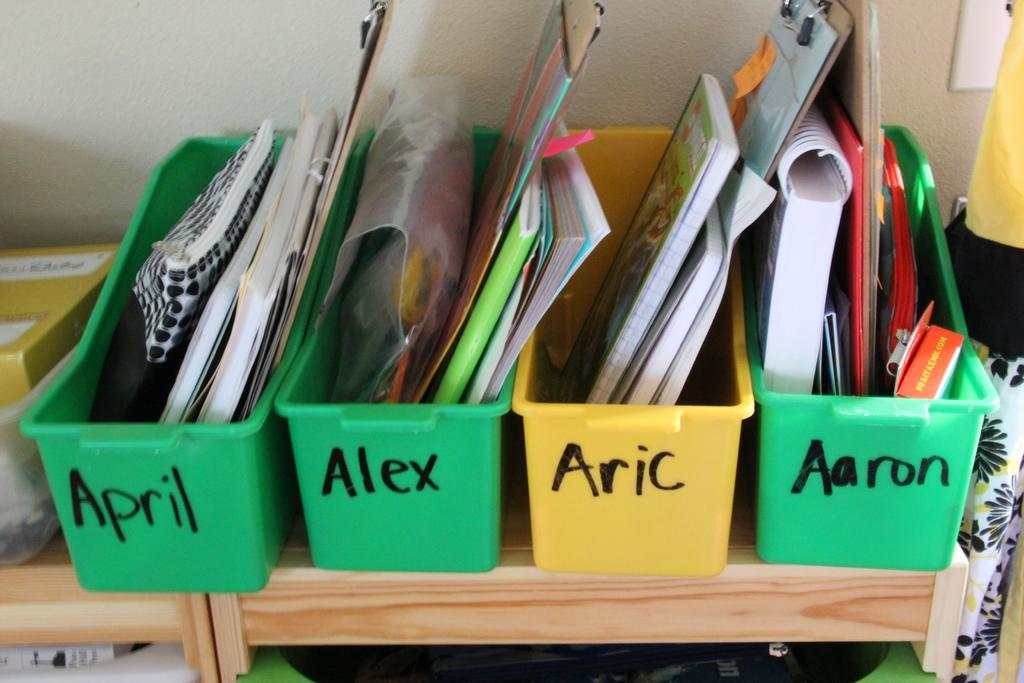<image>
Offer a succinct explanation of the picture presented. Four school supplies containers with names written on them, all of which start with the letter "A". 